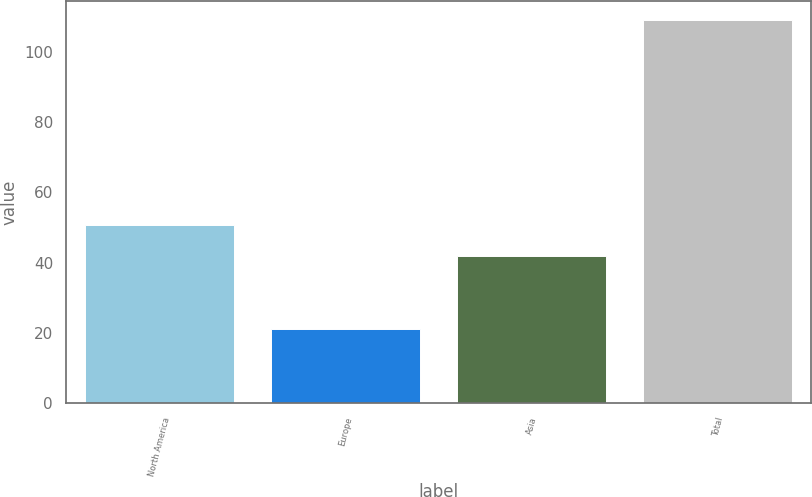Convert chart. <chart><loc_0><loc_0><loc_500><loc_500><bar_chart><fcel>North America<fcel>Europe<fcel>Asia<fcel>Total<nl><fcel>50.8<fcel>21<fcel>42<fcel>109<nl></chart> 